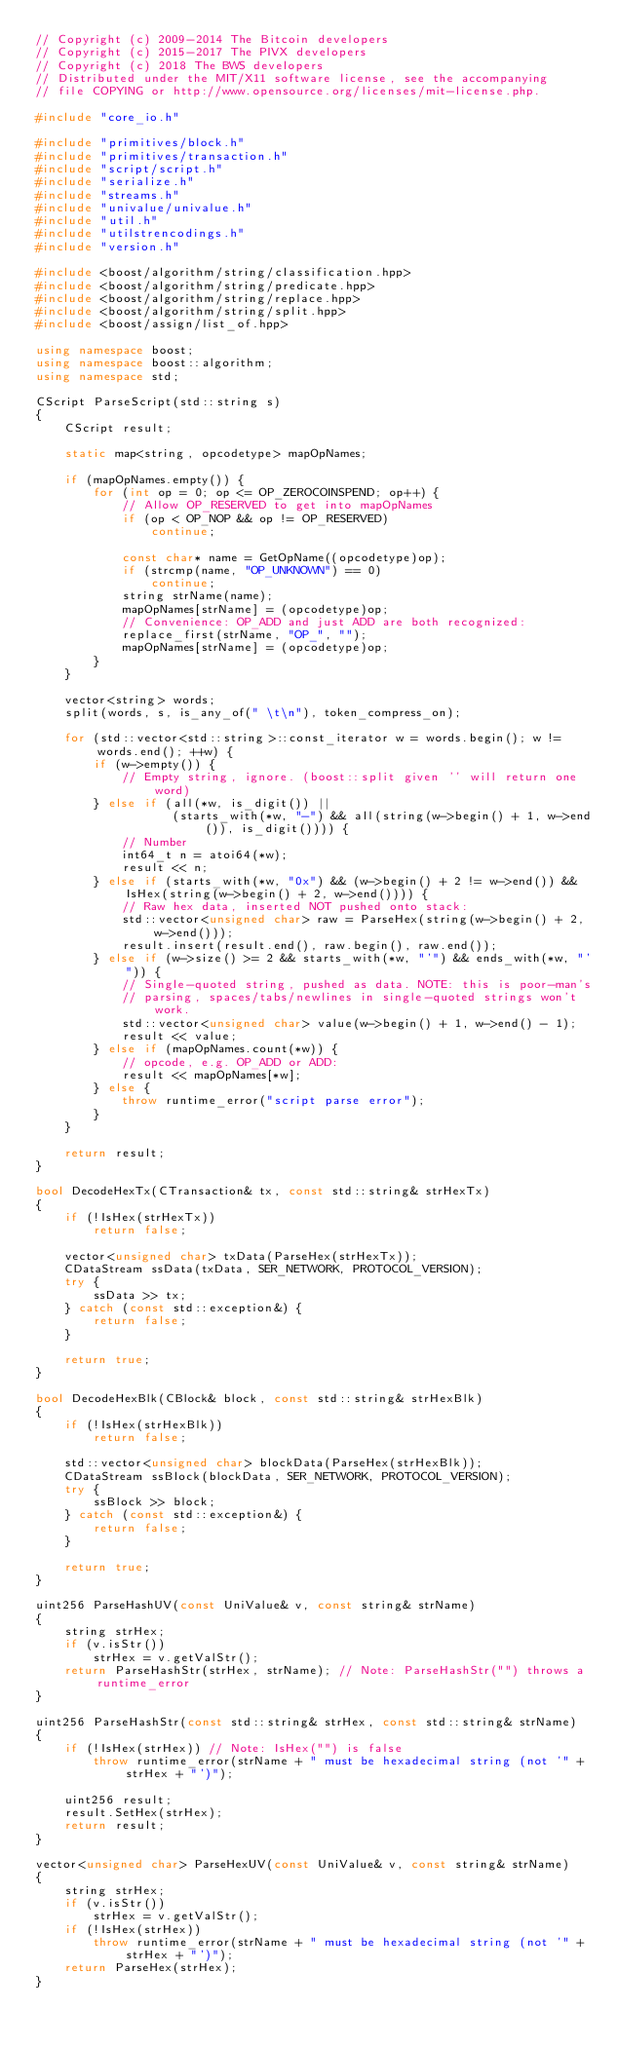<code> <loc_0><loc_0><loc_500><loc_500><_C++_>// Copyright (c) 2009-2014 The Bitcoin developers
// Copyright (c) 2015-2017 The PIVX developers
// Copyright (c) 2018 The BWS developers
// Distributed under the MIT/X11 software license, see the accompanying
// file COPYING or http://www.opensource.org/licenses/mit-license.php.

#include "core_io.h"

#include "primitives/block.h"
#include "primitives/transaction.h"
#include "script/script.h"
#include "serialize.h"
#include "streams.h"
#include "univalue/univalue.h"
#include "util.h"
#include "utilstrencodings.h"
#include "version.h"

#include <boost/algorithm/string/classification.hpp>
#include <boost/algorithm/string/predicate.hpp>
#include <boost/algorithm/string/replace.hpp>
#include <boost/algorithm/string/split.hpp>
#include <boost/assign/list_of.hpp>

using namespace boost;
using namespace boost::algorithm;
using namespace std;

CScript ParseScript(std::string s)
{
    CScript result;

    static map<string, opcodetype> mapOpNames;

    if (mapOpNames.empty()) {
        for (int op = 0; op <= OP_ZEROCOINSPEND; op++) {
            // Allow OP_RESERVED to get into mapOpNames
            if (op < OP_NOP && op != OP_RESERVED)
                continue;

            const char* name = GetOpName((opcodetype)op);
            if (strcmp(name, "OP_UNKNOWN") == 0)
                continue;
            string strName(name);
            mapOpNames[strName] = (opcodetype)op;
            // Convenience: OP_ADD and just ADD are both recognized:
            replace_first(strName, "OP_", "");
            mapOpNames[strName] = (opcodetype)op;
        }
    }

    vector<string> words;
    split(words, s, is_any_of(" \t\n"), token_compress_on);

    for (std::vector<std::string>::const_iterator w = words.begin(); w != words.end(); ++w) {
        if (w->empty()) {
            // Empty string, ignore. (boost::split given '' will return one word)
        } else if (all(*w, is_digit()) ||
                   (starts_with(*w, "-") && all(string(w->begin() + 1, w->end()), is_digit()))) {
            // Number
            int64_t n = atoi64(*w);
            result << n;
        } else if (starts_with(*w, "0x") && (w->begin() + 2 != w->end()) && IsHex(string(w->begin() + 2, w->end()))) {
            // Raw hex data, inserted NOT pushed onto stack:
            std::vector<unsigned char> raw = ParseHex(string(w->begin() + 2, w->end()));
            result.insert(result.end(), raw.begin(), raw.end());
        } else if (w->size() >= 2 && starts_with(*w, "'") && ends_with(*w, "'")) {
            // Single-quoted string, pushed as data. NOTE: this is poor-man's
            // parsing, spaces/tabs/newlines in single-quoted strings won't work.
            std::vector<unsigned char> value(w->begin() + 1, w->end() - 1);
            result << value;
        } else if (mapOpNames.count(*w)) {
            // opcode, e.g. OP_ADD or ADD:
            result << mapOpNames[*w];
        } else {
            throw runtime_error("script parse error");
        }
    }

    return result;
}

bool DecodeHexTx(CTransaction& tx, const std::string& strHexTx)
{
    if (!IsHex(strHexTx))
        return false;

    vector<unsigned char> txData(ParseHex(strHexTx));
    CDataStream ssData(txData, SER_NETWORK, PROTOCOL_VERSION);
    try {
        ssData >> tx;
    } catch (const std::exception&) {
        return false;
    }

    return true;
}

bool DecodeHexBlk(CBlock& block, const std::string& strHexBlk)
{
    if (!IsHex(strHexBlk))
        return false;

    std::vector<unsigned char> blockData(ParseHex(strHexBlk));
    CDataStream ssBlock(blockData, SER_NETWORK, PROTOCOL_VERSION);
    try {
        ssBlock >> block;
    } catch (const std::exception&) {
        return false;
    }

    return true;
}

uint256 ParseHashUV(const UniValue& v, const string& strName)
{
    string strHex;
    if (v.isStr())
        strHex = v.getValStr();
    return ParseHashStr(strHex, strName); // Note: ParseHashStr("") throws a runtime_error
}

uint256 ParseHashStr(const std::string& strHex, const std::string& strName)
{
    if (!IsHex(strHex)) // Note: IsHex("") is false
        throw runtime_error(strName + " must be hexadecimal string (not '" + strHex + "')");

    uint256 result;
    result.SetHex(strHex);
    return result;
}

vector<unsigned char> ParseHexUV(const UniValue& v, const string& strName)
{
    string strHex;
    if (v.isStr())
        strHex = v.getValStr();
    if (!IsHex(strHex))
        throw runtime_error(strName + " must be hexadecimal string (not '" + strHex + "')");
    return ParseHex(strHex);
}
</code> 